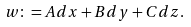<formula> <loc_0><loc_0><loc_500><loc_500>w \colon = A d x + B d y + C d z .</formula> 